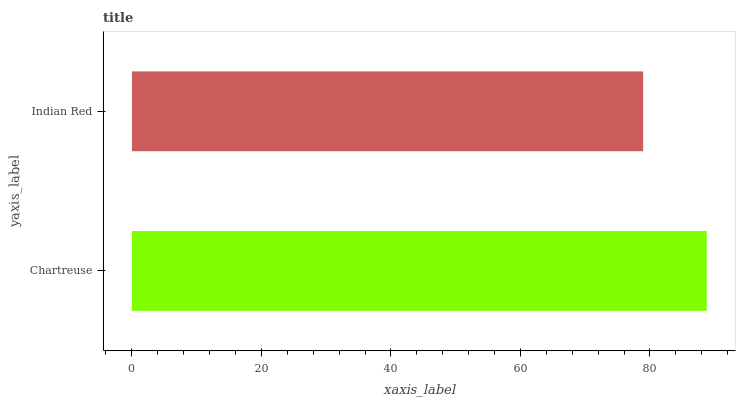Is Indian Red the minimum?
Answer yes or no. Yes. Is Chartreuse the maximum?
Answer yes or no. Yes. Is Indian Red the maximum?
Answer yes or no. No. Is Chartreuse greater than Indian Red?
Answer yes or no. Yes. Is Indian Red less than Chartreuse?
Answer yes or no. Yes. Is Indian Red greater than Chartreuse?
Answer yes or no. No. Is Chartreuse less than Indian Red?
Answer yes or no. No. Is Chartreuse the high median?
Answer yes or no. Yes. Is Indian Red the low median?
Answer yes or no. Yes. Is Indian Red the high median?
Answer yes or no. No. Is Chartreuse the low median?
Answer yes or no. No. 